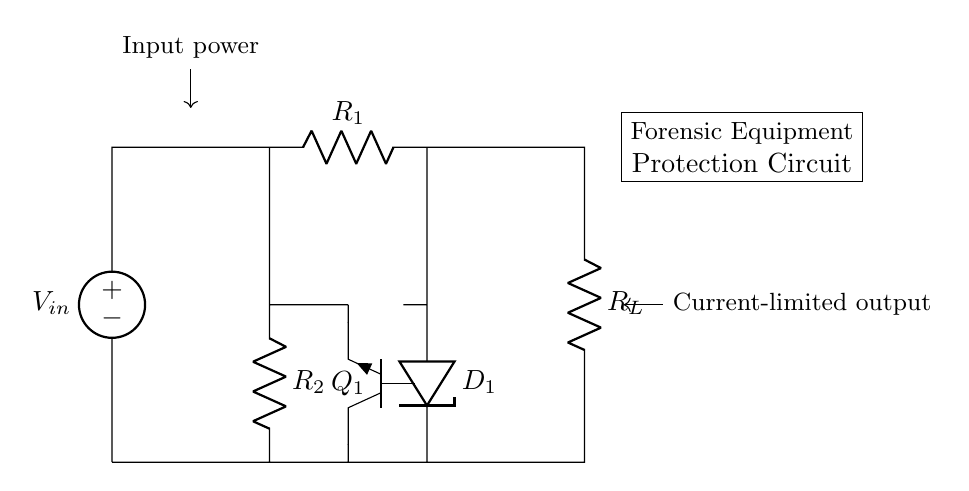What is the input voltage source in this circuit? The input voltage source is labeled as V_{in} in the circuit diagram, indicating where power is supplied to the circuit.
Answer: V_in What type of transistor is used as Q_1? The transistor labeled Q_1 is an NPN type transistor, as indicated by the symbol used in the diagram.
Answer: NPN What is the purpose of D_1 in this circuit? The diode D_1 is used for preventing reverse voltage, which protects sensitive components by allowing current flow in only one direction, effectively clamping any negative transients.
Answer: Protection What are the resistors R_1 and R_2 used for? Resistor R_1 is part of the input circuitry, while R_2 is used for current limiting in conjunction with Q_1, aiding in regulating the output current to protect connected devices.
Answer: Current limiting How many resistors are in the circuit? The circuit contains two resistors, R_1 and R_2, as clearly shown in the diagram.
Answer: Two What is the overall function of this circuit? The circuit is designed to limit the current output to protect sensitive forensic equipment from power surges and other voltage spikes.
Answer: Current limiting regulator What is the relationship between R_L and the delicate forensic equipment? The resistor R_L represents the load which simulates the delicate forensic equipment that the circuit is designed to protect from overcurrent.
Answer: Load protection 